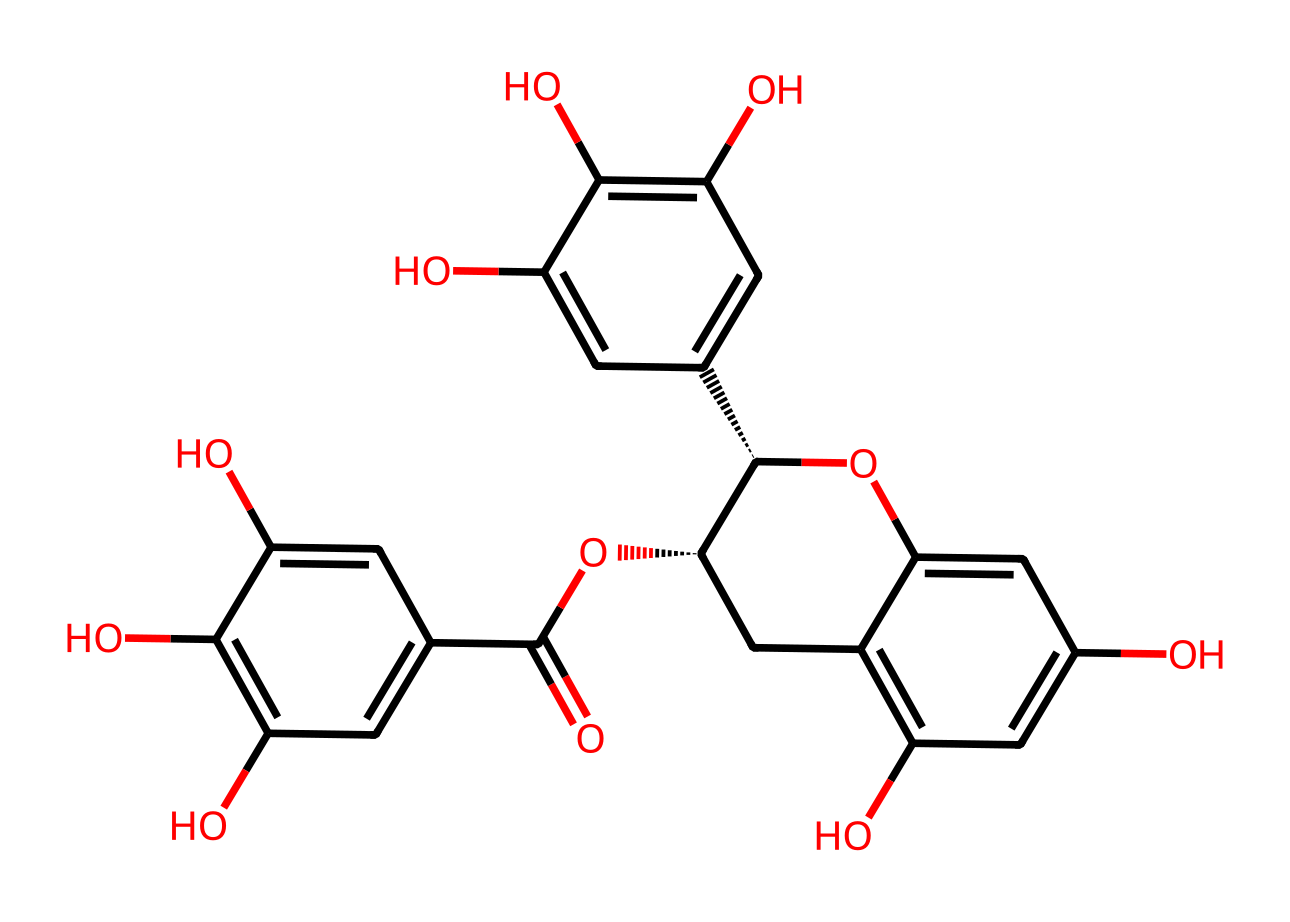What is the molecular formula of epigallocatechin gallate? To determine the molecular formula, we need to examine the atoms present in the SMILES representation. Counting the atoms, we find there are 22 carbon (C), 18 hydrogen (H), and 10 oxygen (O) atoms. Therefore, the molecular formula is C22H18O10.
Answer: C22H18O10 How many rings are present in the structure of epigallocatechin gallate? In analyzing the chemical structure, we notice that there are two distinct benzene rings in the molecule, indicating the presence of two aromatic rings that contribute to the overall complexity of the compound.
Answer: 2 What functional groups are present in epigallocatechin gallate? By examining the structure, we can identify hydroxyl (–OH) groups attached to the carbon rings, as well as an ester linkage indicated by the presence of the oxygen connected to a carbonyl (C=O) group. These functional groups are characteristic of flavonoid compounds.
Answer: hydroxyl and ester How many hydroxyl groups does epigallocatechin gallate have? Looking closely at the chemical structure, we can count five hydroxyl (–OH) groups, which are critical for its antioxidant properties. Each presence of (–OH) contributes significantly to the molecule's reactivity and solubility.
Answer: 5 Is epigallocatechin gallate a phenolic compound? Observing the structure, we see multiple hydroxyl groups attached to aromatic rings. This characteristic makes epigallocatechin gallate a type of phenolic compound, known for its antioxidant properties.
Answer: yes What type of antioxidant activity is associated with epigallocatechin gallate? Epigallocatechin gallate is known for its radical scavenging activity, where it effectively neutralizes free radicals in biological systems, contributing to its health benefits. The multiple hydroxyl groups enhance this capability.
Answer: radical scavenging What characteristic of epigallocatechin gallate contributes to its bioavailability? The presence of hydroxyl groups in the molecule affects the solubility and absorption in biological systems, leading to increased bioavailability of epigallocatechin gallate when ingested. This is vital for its effectiveness as an antioxidant.
Answer: hydroxyl groups 